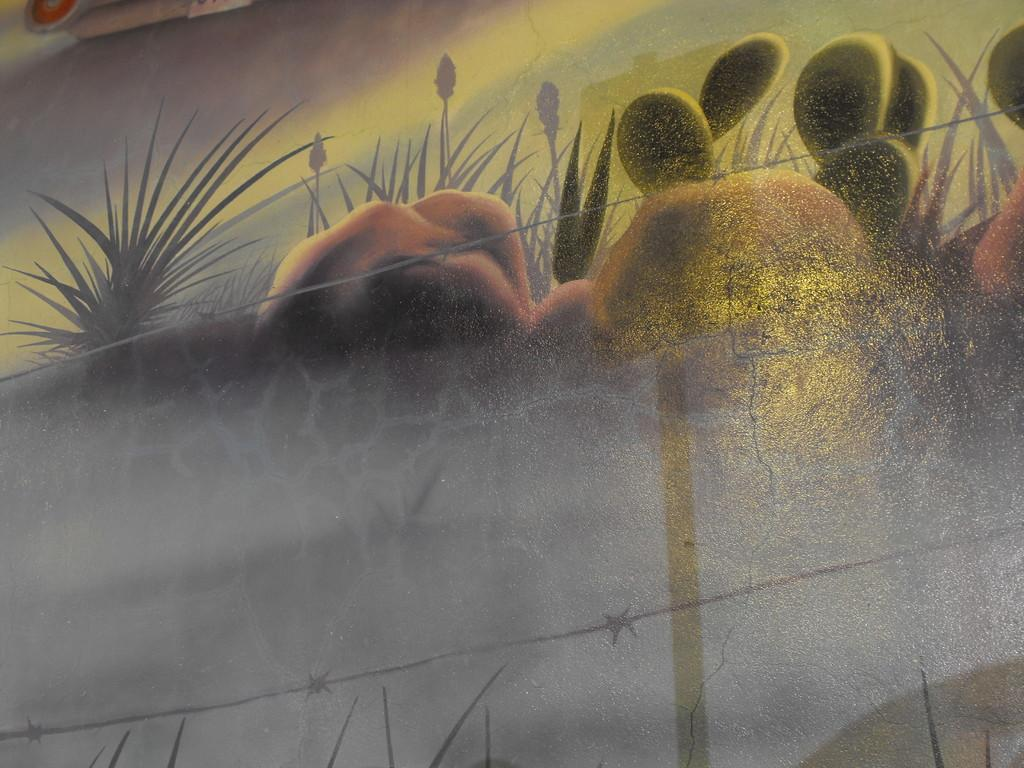What is on the wall in the image? There is a painting on the wall in the image. How far is the dock from the painting in the image? There is no dock present in the image, so it is not possible to determine the distance between the dock and the painting. 